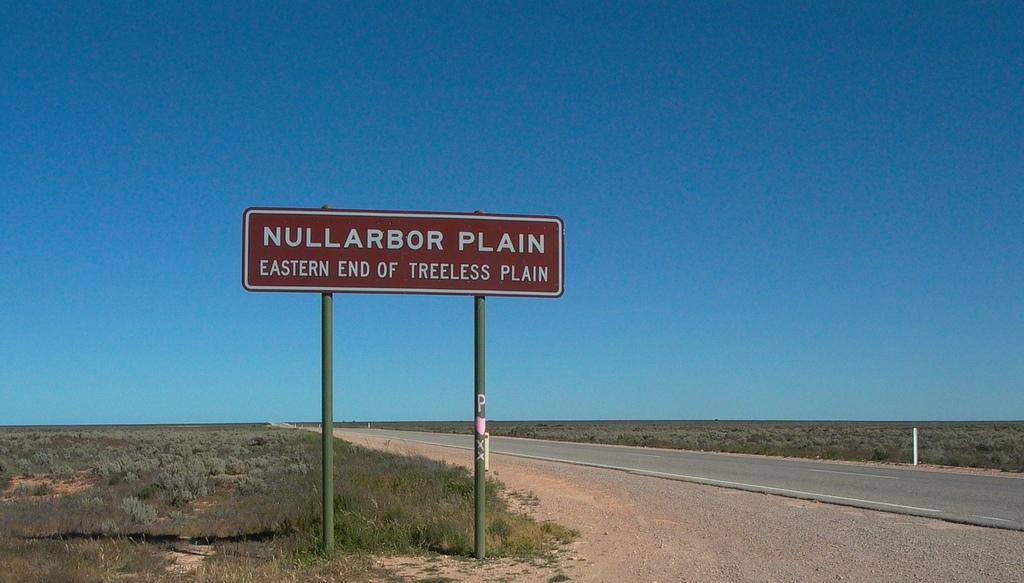Provide a one-sentence caption for the provided image. A road with a brown sign reading Eastern end of treeless plain. 